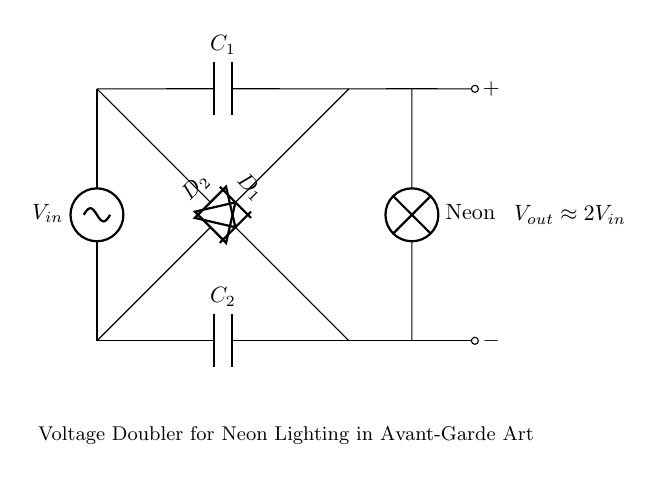What is the input voltage designation in this circuit? The input voltage is labeled as V_in, representing the alternating current voltage supplied to the circuit.
Answer: V_in How many capacitors are present in the diagram? The circuit diagram shows two capacitors, labeled as C_1 and C_2, which are used for voltage doubling.
Answer: 2 What is the expected output voltage compared to the input? The output voltage, indicated in the diagram, is approximately twice the input voltage, meaning that it doubles the input value.
Answer: 2V_in Which components are responsible for rectification in this circuit? The components labeled D_1 and D_2 are diodes, which perform rectification by allowing current to flow in one direction only, thus converting AC to DC.
Answer: D_1 and D_2 What is the function of the load in this circuit? The load is represented by the neon lamp, which serves as the application for the converted electrical energy, displaying the output from the voltage doubler circuit.
Answer: Neon How do the capacitors contribute to the function of the circuit? The capacitors store energy during the high voltage phase of the AC input and release it during the low phase, effectively multiplying the input voltage to achieve the output needed for the neon light.
Answer: Energy storage 